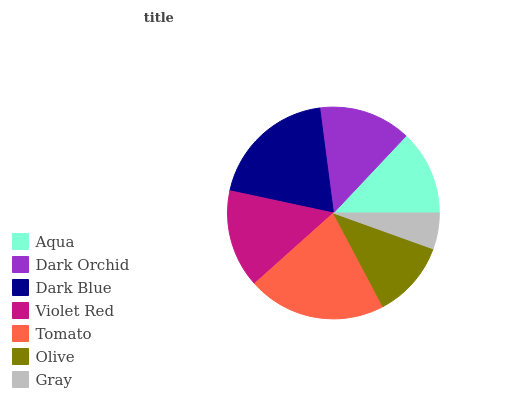Is Gray the minimum?
Answer yes or no. Yes. Is Tomato the maximum?
Answer yes or no. Yes. Is Dark Orchid the minimum?
Answer yes or no. No. Is Dark Orchid the maximum?
Answer yes or no. No. Is Dark Orchid greater than Aqua?
Answer yes or no. Yes. Is Aqua less than Dark Orchid?
Answer yes or no. Yes. Is Aqua greater than Dark Orchid?
Answer yes or no. No. Is Dark Orchid less than Aqua?
Answer yes or no. No. Is Dark Orchid the high median?
Answer yes or no. Yes. Is Dark Orchid the low median?
Answer yes or no. Yes. Is Aqua the high median?
Answer yes or no. No. Is Olive the low median?
Answer yes or no. No. 